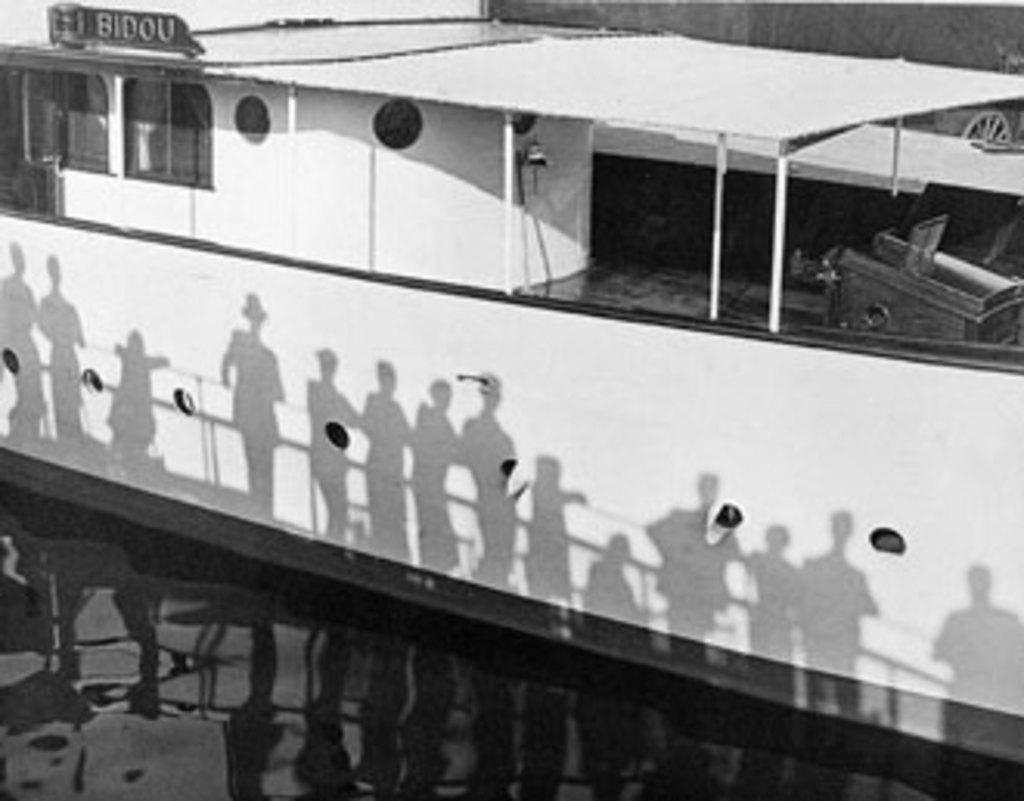What is the most likely name of this boat?
Ensure brevity in your answer.  Bidou. 